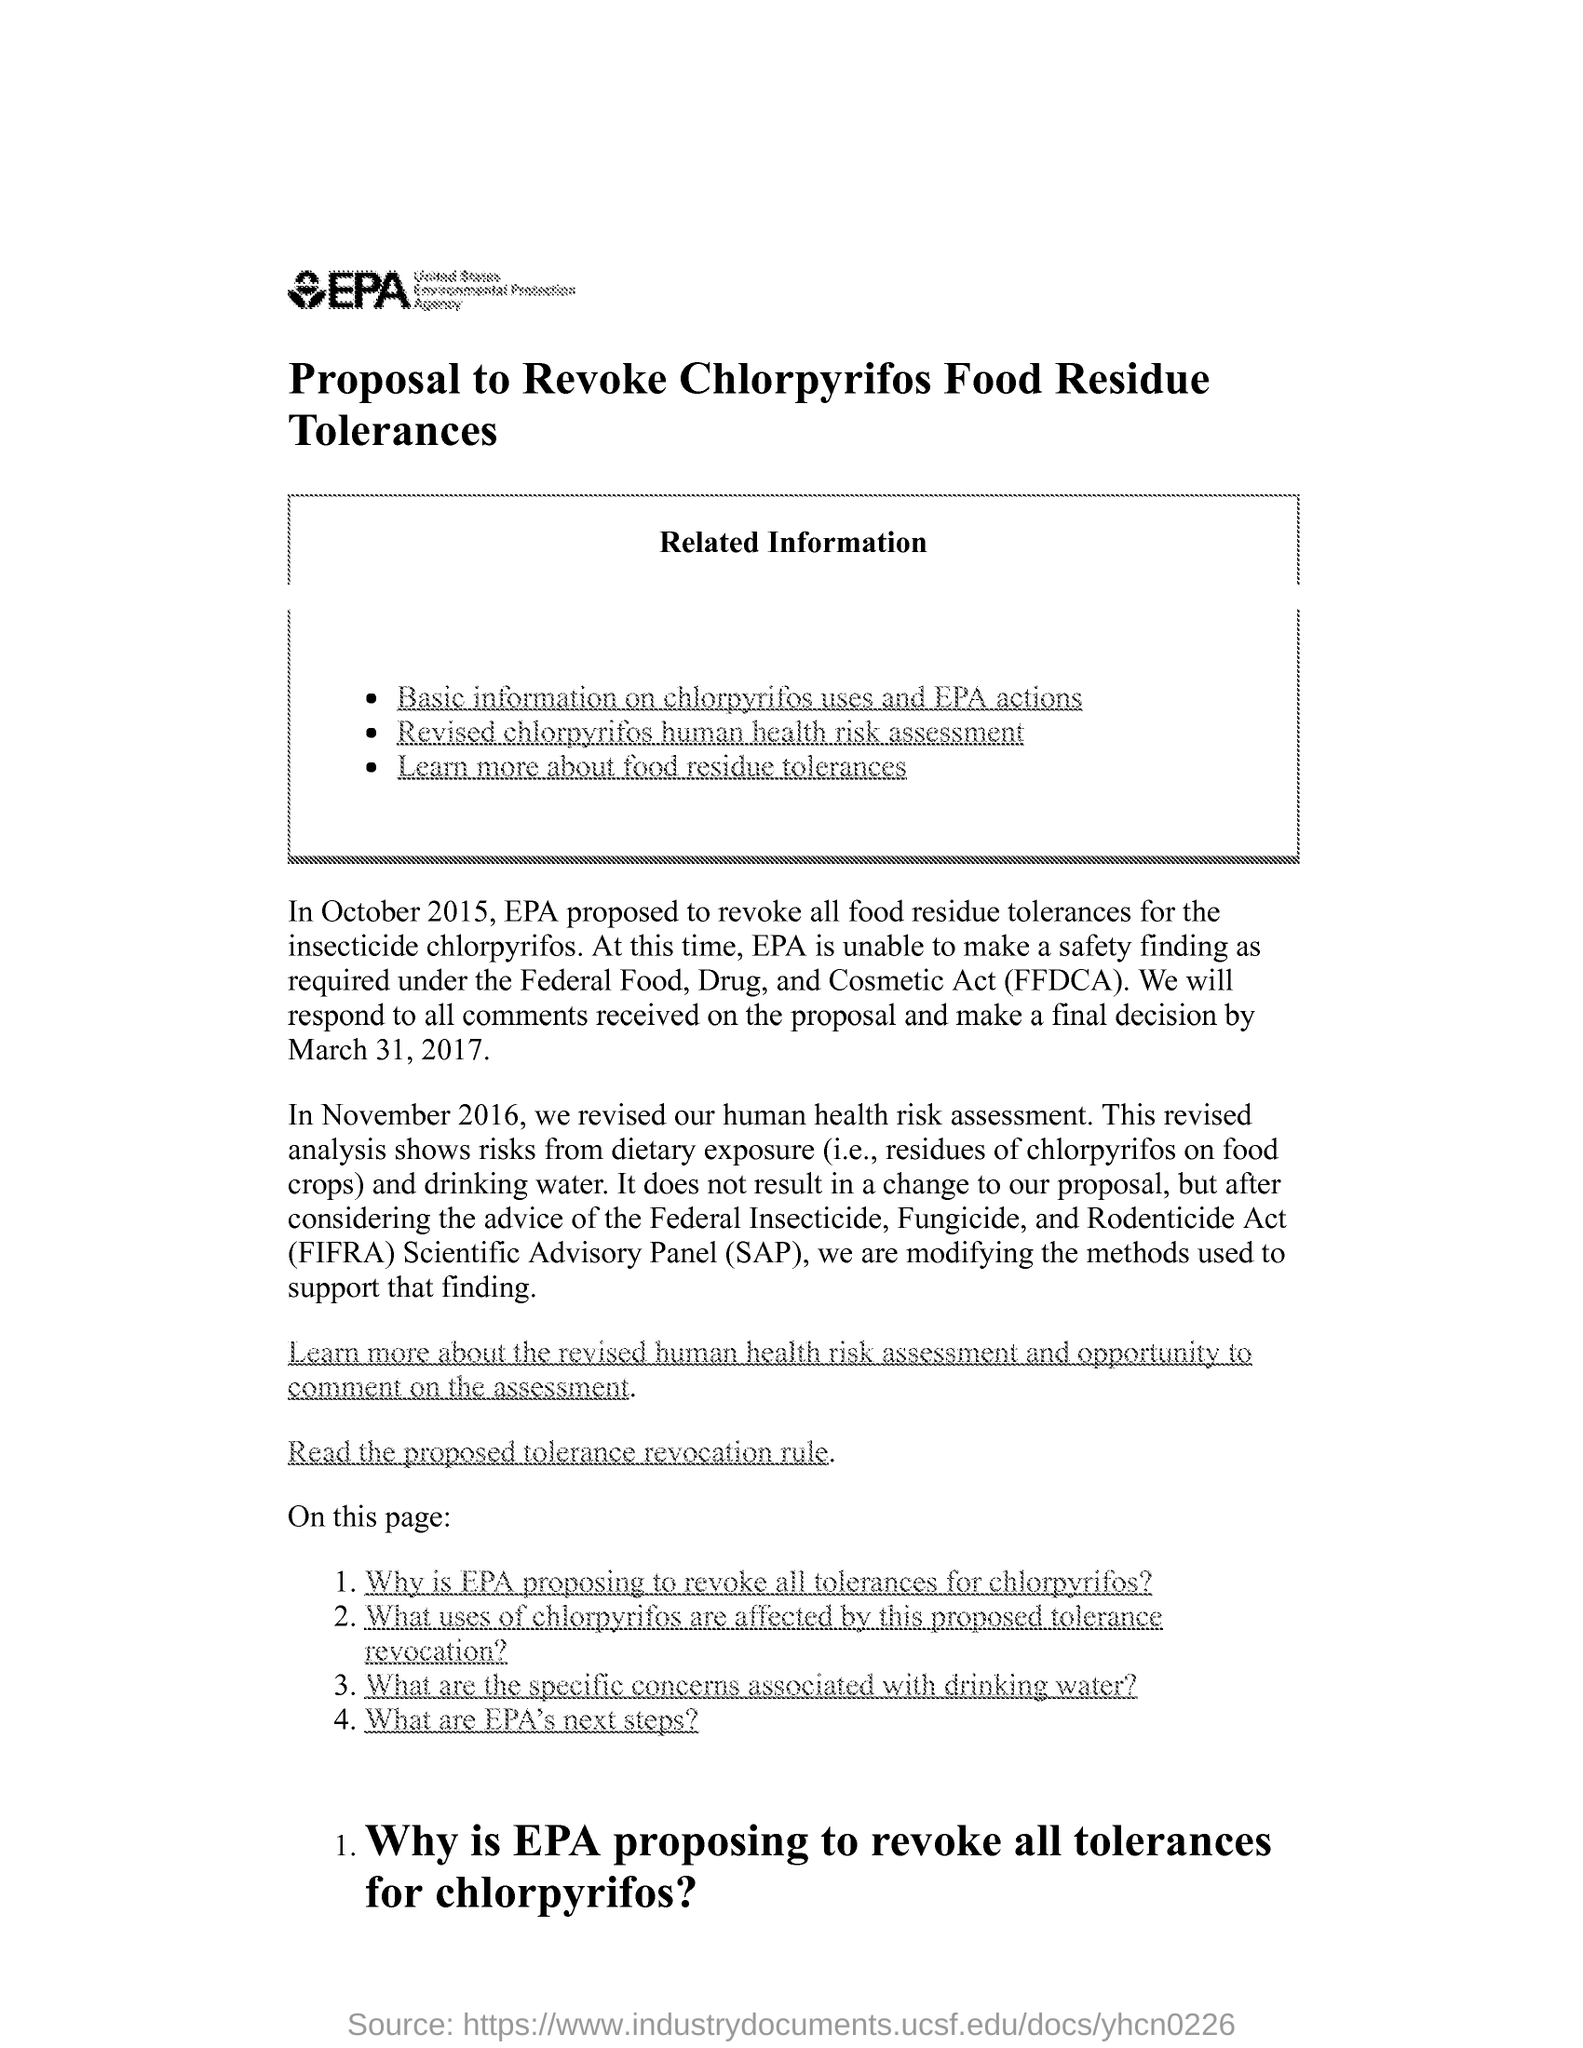What is the title written inside the box?
Your answer should be very brief. Related Information. 